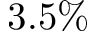<formula> <loc_0><loc_0><loc_500><loc_500>3 . 5 \%</formula> 